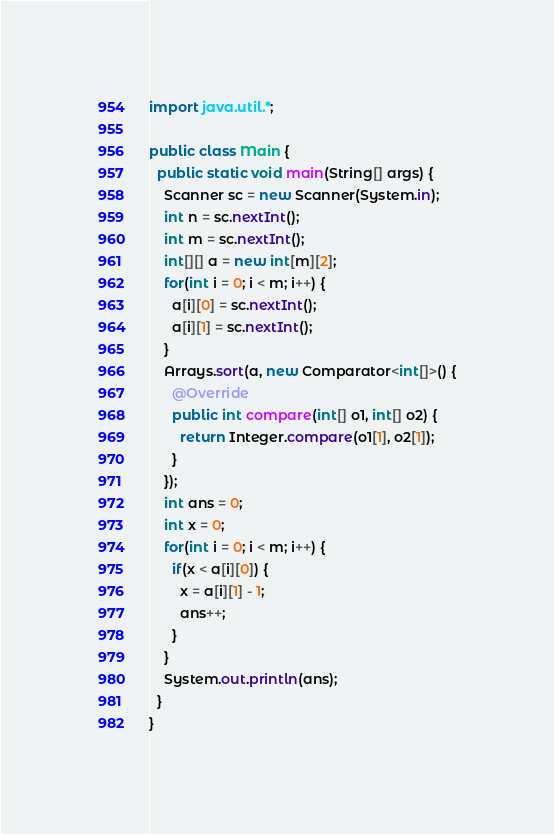<code> <loc_0><loc_0><loc_500><loc_500><_Java_>import java.util.*;

public class Main {
  public static void main(String[] args) {
    Scanner sc = new Scanner(System.in);
    int n = sc.nextInt();
    int m = sc.nextInt();
    int[][] a = new int[m][2];
    for(int i = 0; i < m; i++) {
      a[i][0] = sc.nextInt();
      a[i][1] = sc.nextInt();
    }
    Arrays.sort(a, new Comparator<int[]>() {
      @Override
      public int compare(int[] o1, int[] o2) {
        return Integer.compare(o1[1], o2[1]);
      }
    });
    int ans = 0;
    int x = 0;
    for(int i = 0; i < m; i++) {
      if(x < a[i][0]) {
        x = a[i][1] - 1;
        ans++;
      }
    }
    System.out.println(ans);
  }
}</code> 